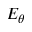<formula> <loc_0><loc_0><loc_500><loc_500>E _ { \theta }</formula> 